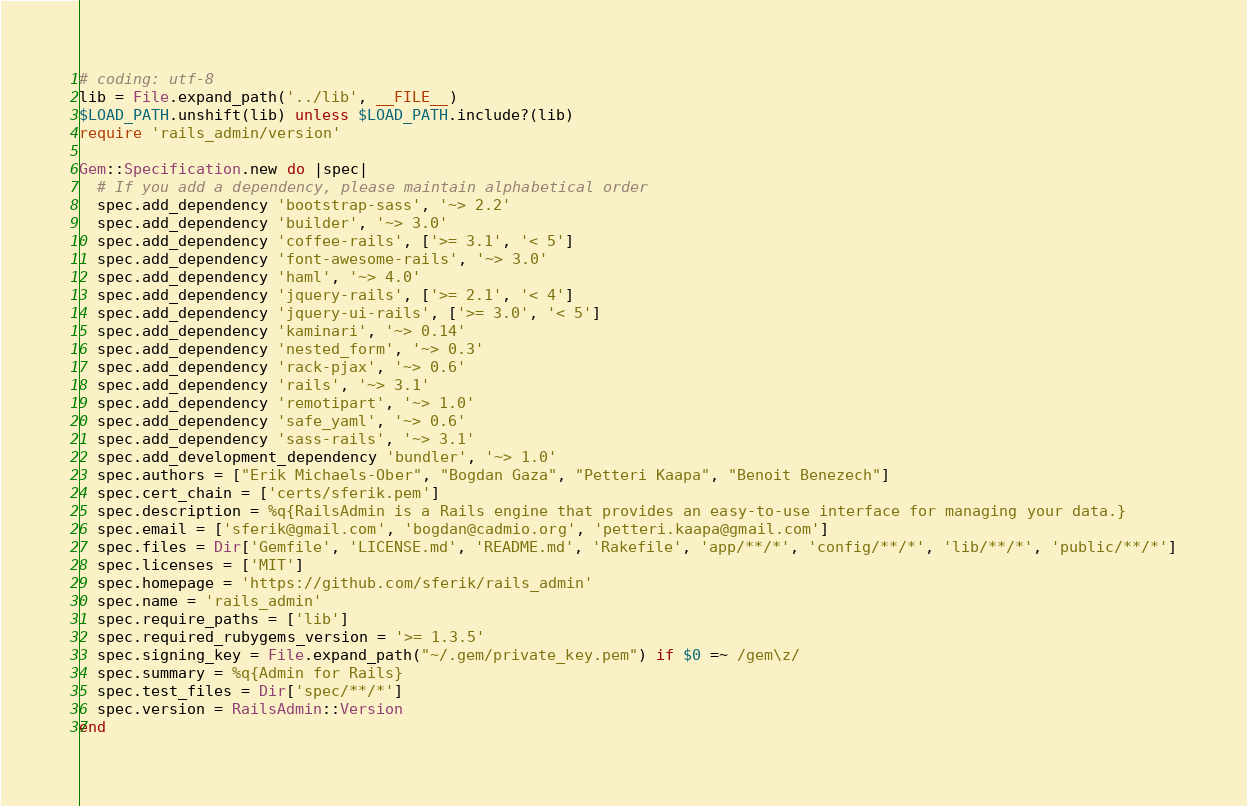Convert code to text. <code><loc_0><loc_0><loc_500><loc_500><_Ruby_># coding: utf-8
lib = File.expand_path('../lib', __FILE__)
$LOAD_PATH.unshift(lib) unless $LOAD_PATH.include?(lib)
require 'rails_admin/version'

Gem::Specification.new do |spec|
  # If you add a dependency, please maintain alphabetical order
  spec.add_dependency 'bootstrap-sass', '~> 2.2'
  spec.add_dependency 'builder', '~> 3.0'
  spec.add_dependency 'coffee-rails', ['>= 3.1', '< 5']
  spec.add_dependency 'font-awesome-rails', '~> 3.0'
  spec.add_dependency 'haml', '~> 4.0'
  spec.add_dependency 'jquery-rails', ['>= 2.1', '< 4']
  spec.add_dependency 'jquery-ui-rails', ['>= 3.0', '< 5']
  spec.add_dependency 'kaminari', '~> 0.14'
  spec.add_dependency 'nested_form', '~> 0.3'
  spec.add_dependency 'rack-pjax', '~> 0.6'
  spec.add_dependency 'rails', '~> 3.1'
  spec.add_dependency 'remotipart', '~> 1.0'
  spec.add_dependency 'safe_yaml', '~> 0.6'
  spec.add_dependency 'sass-rails', '~> 3.1'
  spec.add_development_dependency 'bundler', '~> 1.0'
  spec.authors = ["Erik Michaels-Ober", "Bogdan Gaza", "Petteri Kaapa", "Benoit Benezech"]
  spec.cert_chain = ['certs/sferik.pem']
  spec.description = %q{RailsAdmin is a Rails engine that provides an easy-to-use interface for managing your data.}
  spec.email = ['sferik@gmail.com', 'bogdan@cadmio.org', 'petteri.kaapa@gmail.com']
  spec.files = Dir['Gemfile', 'LICENSE.md', 'README.md', 'Rakefile', 'app/**/*', 'config/**/*', 'lib/**/*', 'public/**/*']
  spec.licenses = ['MIT']
  spec.homepage = 'https://github.com/sferik/rails_admin'
  spec.name = 'rails_admin'
  spec.require_paths = ['lib']
  spec.required_rubygems_version = '>= 1.3.5'
  spec.signing_key = File.expand_path("~/.gem/private_key.pem") if $0 =~ /gem\z/
  spec.summary = %q{Admin for Rails}
  spec.test_files = Dir['spec/**/*']
  spec.version = RailsAdmin::Version
end
</code> 